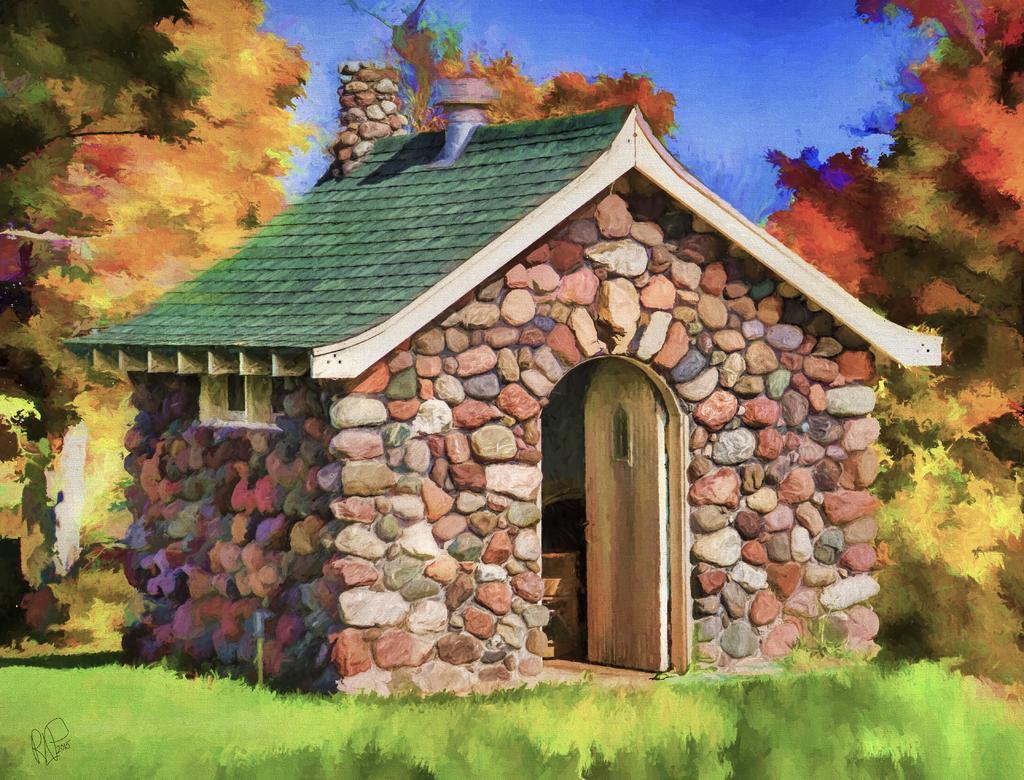In one or two sentences, can you explain what this image depicts? In this image it looks like an art in which we can see there is a house in the middle. At the bottom there is grass. At the top there is the sky. There are trees on either side of the house. 